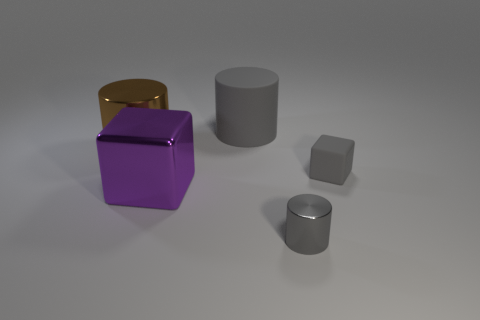Add 2 purple blocks. How many objects exist? 7 Subtract all blocks. How many objects are left? 3 Add 5 metal objects. How many metal objects are left? 8 Add 1 large gray things. How many large gray things exist? 2 Subtract 0 green blocks. How many objects are left? 5 Subtract all tiny metallic cylinders. Subtract all large brown things. How many objects are left? 3 